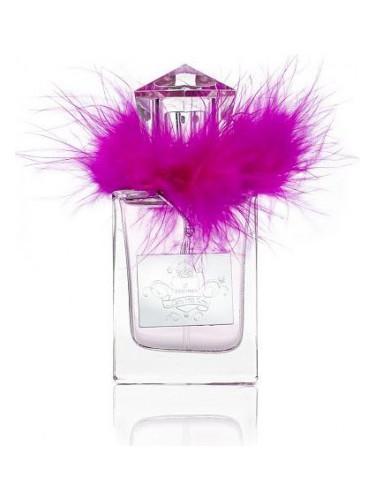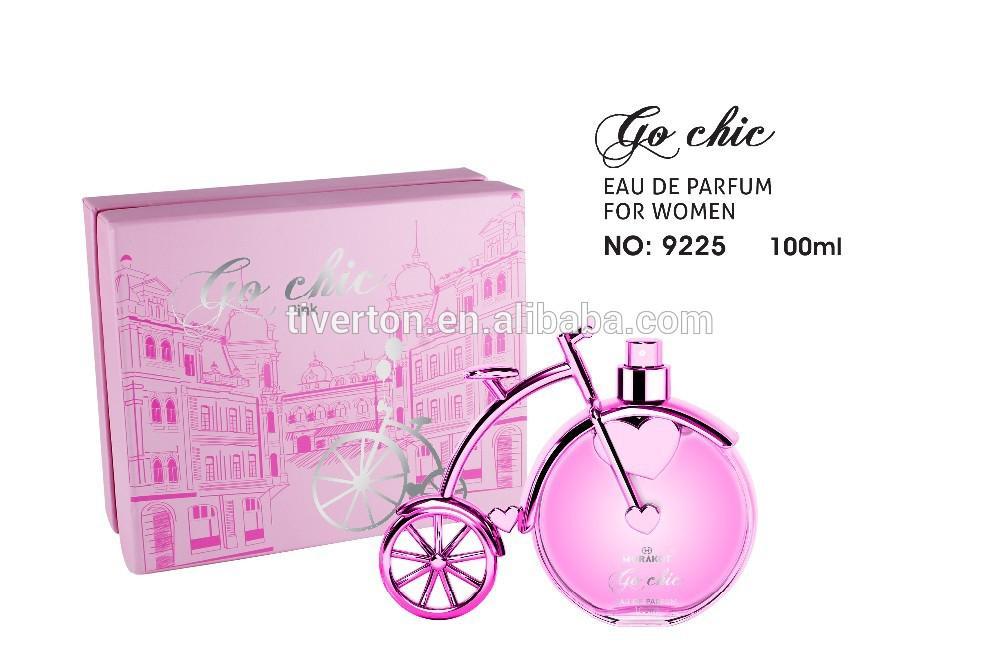The first image is the image on the left, the second image is the image on the right. Given the left and right images, does the statement "there is only one cologne on the right image" hold true? Answer yes or no. Yes. 